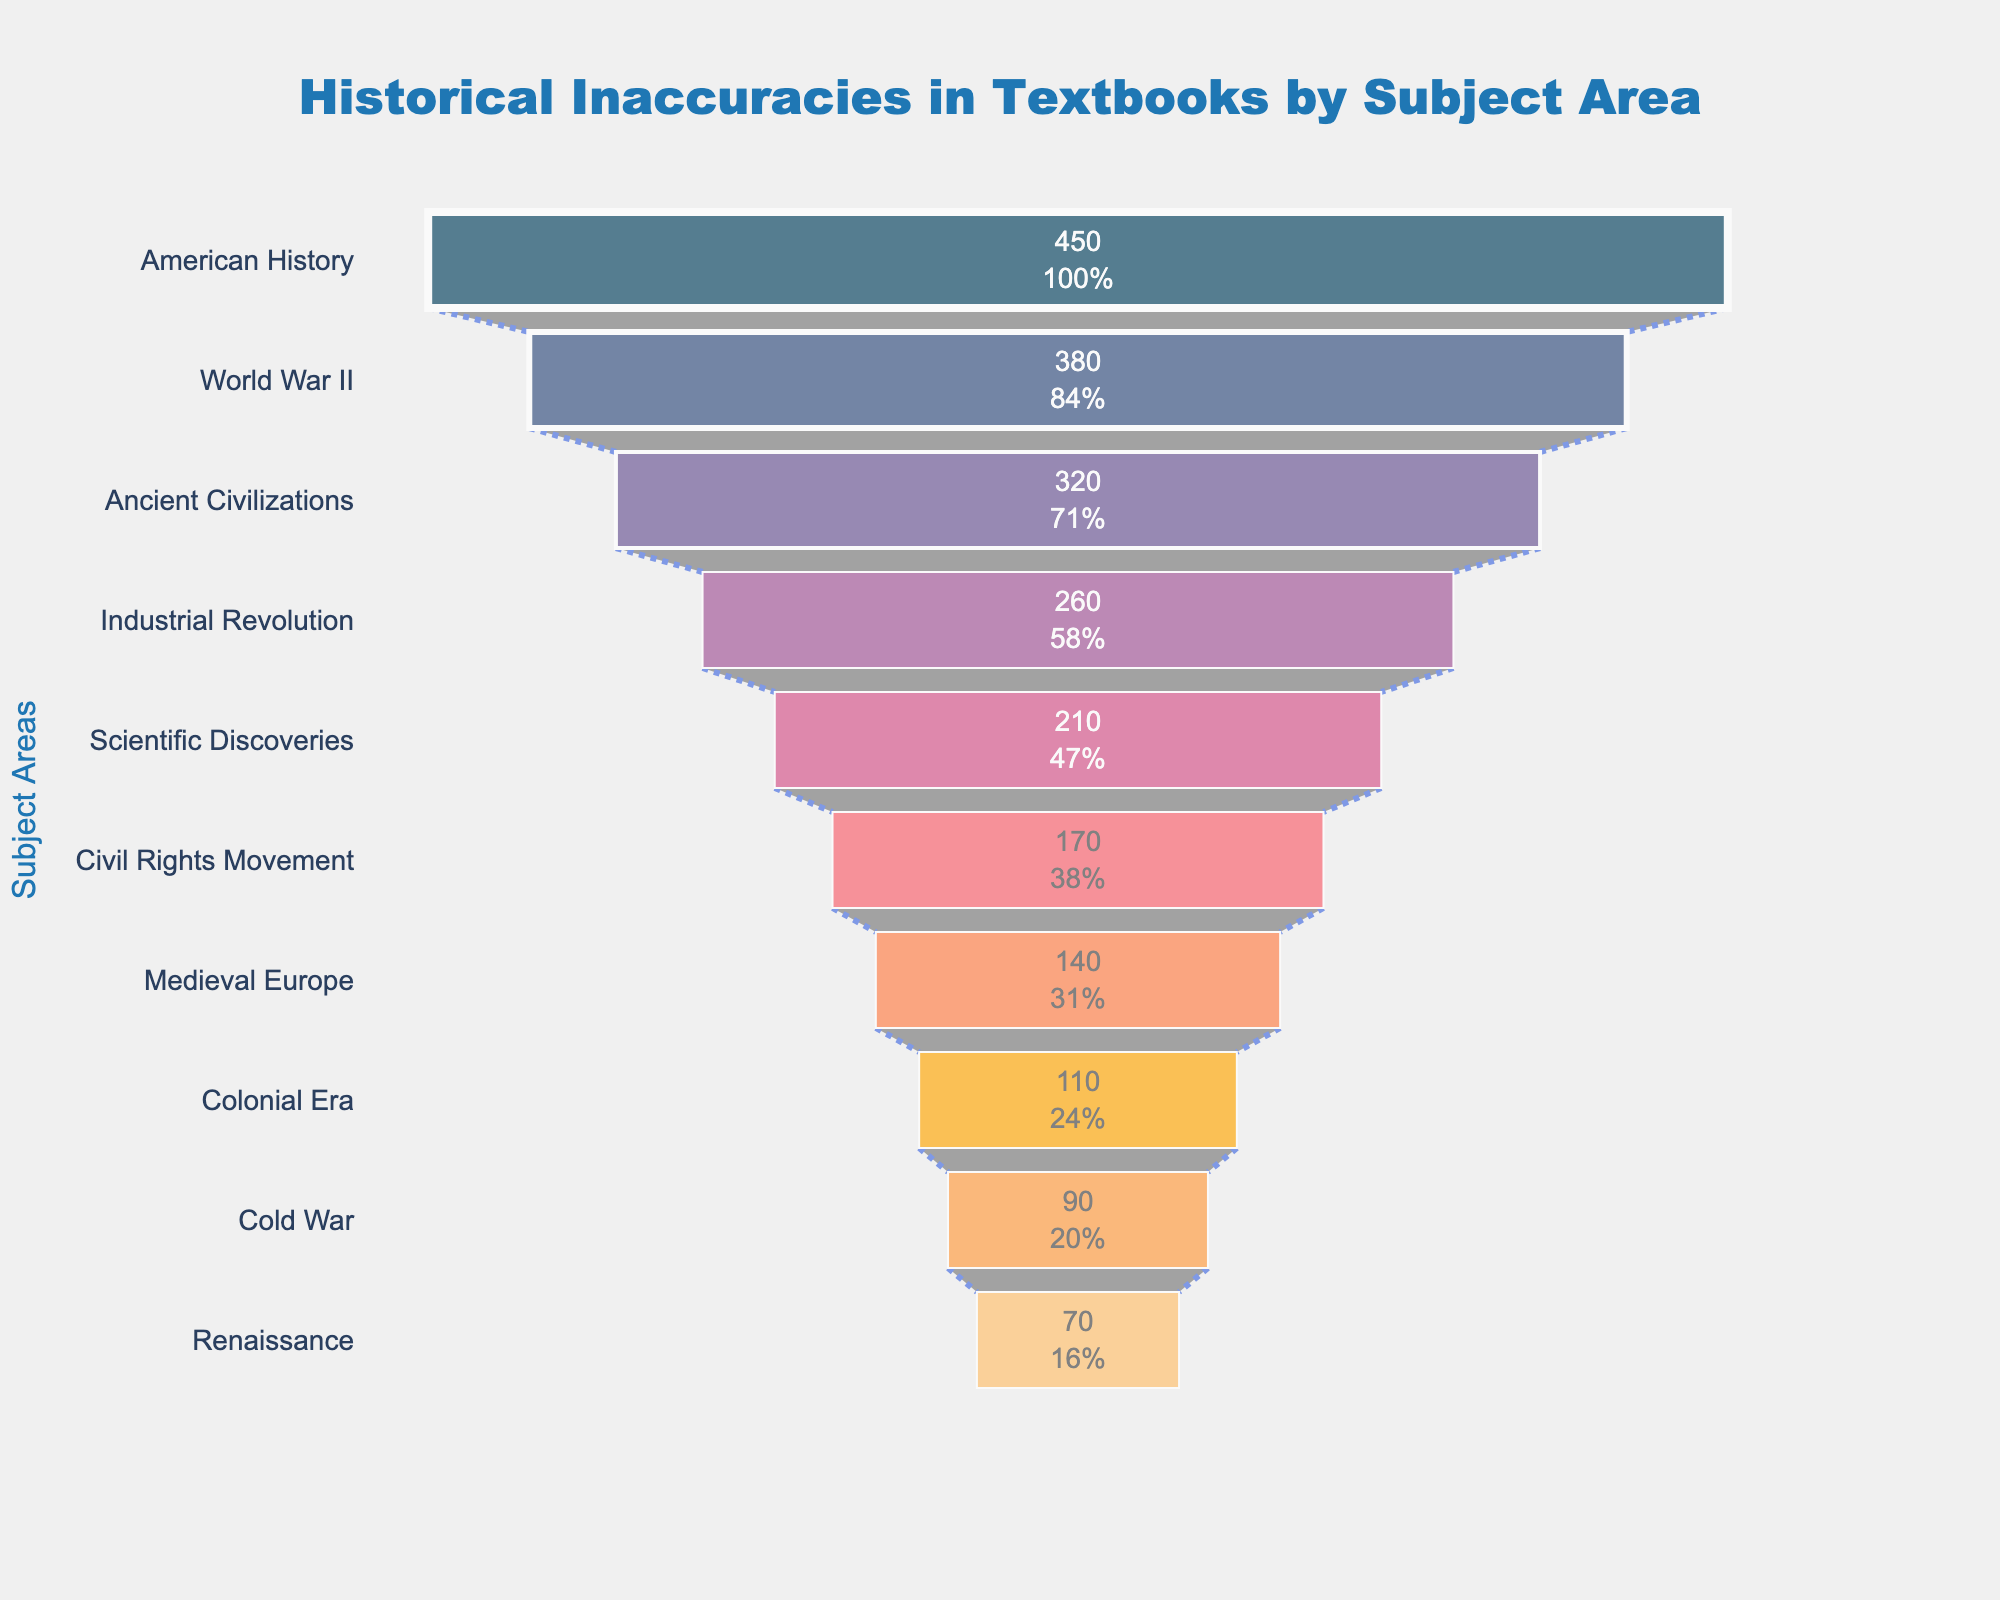What is the subject area with the highest number of historical inaccuracies? The subject area with the highest number of historical inaccuracies can be found at the top of the funnel chart. In this chart, the topmost section represents "American History" with 450 inaccuracies.
Answer: American History Which subject has the second most frequent inaccuracies? To find the second most frequent inaccuracies, we look for the section immediately below the top of the funnel chart. That subject area is "World War II" with 380 inaccuracies.
Answer: World War II What is the total number of inaccuracies for "Scientific Discoveries" and "Civil Rights Movement" combined? We need to sum the inaccuracies for both subject areas. "Scientific Discoveries" has 210 inaccuracies and "Civil Rights Movement" has 170 inaccuracies. Adding them together gives 210 + 170.
Answer: 380 How does the number of inaccuracies in "Ancient Civilizations" compare to that in "Medieval Europe"? To compare, we subtract the inaccuracies of "Medieval Europe" from "Ancient Civilizations". "Ancient Civilizations" has 320 inaccuracies, and "Medieval Europe" has 140 inaccuracies. 320 - 140 = 180.
Answer: 180 more in Ancient Civilizations What percentage of total inaccuracies does "Industrial Revolution" contribute? Total inaccuracies can be calculated by summing all subjects' inaccuracies. Then, the number of inaccuracies in "Industrial Revolution" is divided by this total and multiplied by 100 to find the percentage. Summing all subjects gives 450 + 380 + 320 + 260 + 210 + 170 + 140 + 110 + 90 + 70 = 2200. The percentage is then (260 / 2200) * 100.
Answer: 11.82% Which subject area has fewer inaccuracies, "Colonial Era" or "Cold War"? To determine which subject area has fewer inaccuracies between "Colonial Era" and "Cold War", compare their values directly. "Colonial Era" has 110 inaccuracies, while "Cold War" has 90 inaccuracies.
Answer: Cold War What is the median number of inaccuracies from all the subject areas listed? First, arrange the number of inaccuracies in ascending order: 70, 90, 110, 140, 170, 210, 260, 320, 380, 450. Since there are 10 values, the median is the average of the 5th and 6th values: (170 + 210) / 2.
Answer: 190 What is the range of inaccuracies among the subject areas? The range is found by subtracting the smallest number of inaccuracies from the largest number of inaccuracies. The highest number of inaccuracies is 450 (American History) and the lowest is 70 (Renaissance). Therefore, the range is 450 - 70.
Answer: 380 Which subject has more inaccuracies, "Renaissance" or "Colonial Era"? By how much? To determine which subject has more inaccuracies and by how much, compare the values directly and subtract the smaller from the larger. "Colonial Era" has 110 inaccuracies and "Renaissance" has 70 inaccuracies. The difference is 110 - 70.
Answer: Colonial Era by 40 How does the number of inaccuracies in "American History" compare to the combined inaccuracies in "Medieval Europe" and "Renaissance"? Sum the inaccuracies of "Medieval Europe" and "Renaissance" first to get 140 + 70 = 210. Compare this to "American History" which has 450 inaccuracies. 450 - 210 = 240.
Answer: 240 more in American History 